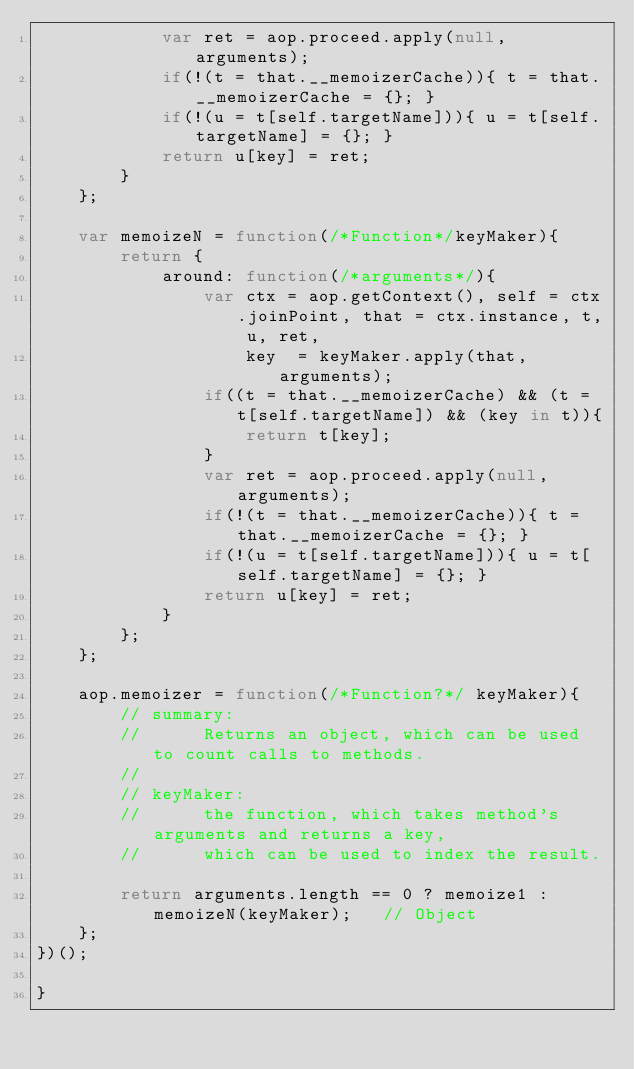<code> <loc_0><loc_0><loc_500><loc_500><_JavaScript_>			var ret = aop.proceed.apply(null, arguments);
			if(!(t = that.__memoizerCache)){ t = that.__memoizerCache = {}; }
			if(!(u = t[self.targetName])){ u = t[self.targetName] = {}; }
			return u[key] = ret;
		}
	};

	var memoizeN = function(/*Function*/keyMaker){
		return {
			around: function(/*arguments*/){
				var ctx = aop.getContext(), self = ctx.joinPoint, that = ctx.instance, t, u, ret,
					key  = keyMaker.apply(that, arguments);
				if((t = that.__memoizerCache) && (t = t[self.targetName]) && (key in t)){
					return t[key];
				}
				var ret = aop.proceed.apply(null, arguments);
				if(!(t = that.__memoizerCache)){ t = that.__memoizerCache = {}; }
				if(!(u = t[self.targetName])){ u = t[self.targetName] = {}; }
				return u[key] = ret;
			}
		};
	};

	aop.memoizer = function(/*Function?*/ keyMaker){
		// summary:
		//		Returns an object, which can be used to count calls to methods.
		//
		// keyMaker:
		//		the function, which takes method's arguments and returns a key,
		//		which can be used to index the result.

		return arguments.length == 0 ? memoize1 : memoizeN(keyMaker);	// Object
	};
})();

}
</code> 